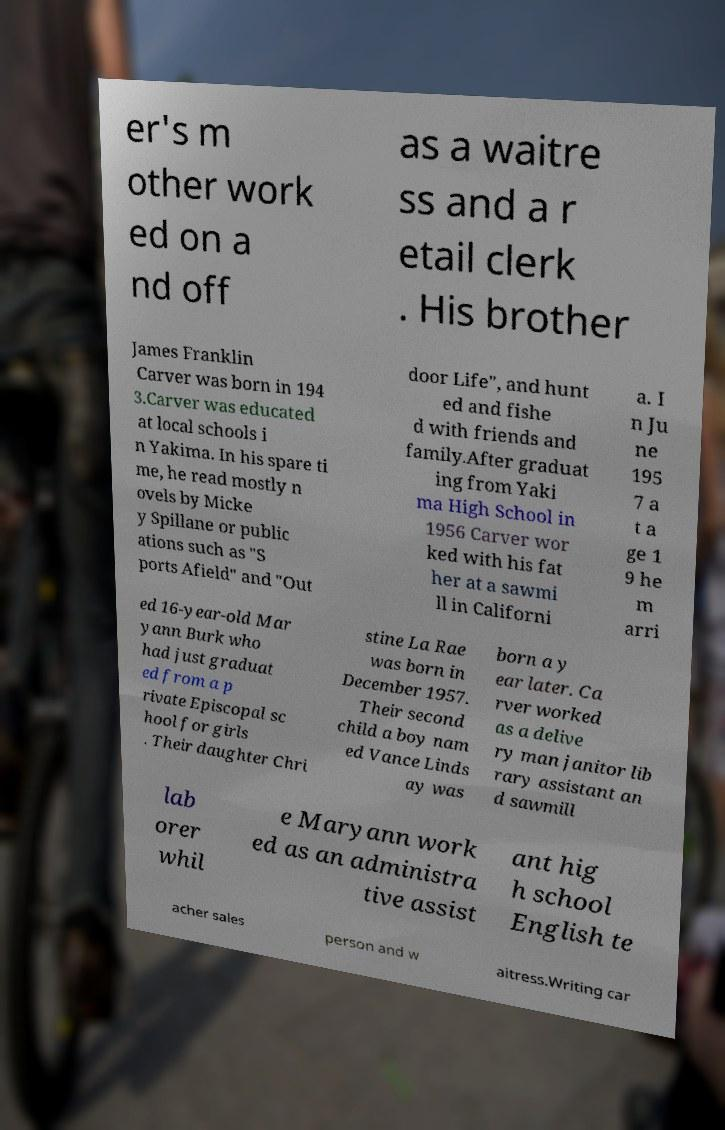Could you extract and type out the text from this image? er's m other work ed on a nd off as a waitre ss and a r etail clerk . His brother James Franklin Carver was born in 194 3.Carver was educated at local schools i n Yakima. In his spare ti me, he read mostly n ovels by Micke y Spillane or public ations such as "S ports Afield" and "Out door Life", and hunt ed and fishe d with friends and family.After graduat ing from Yaki ma High School in 1956 Carver wor ked with his fat her at a sawmi ll in Californi a. I n Ju ne 195 7 a t a ge 1 9 he m arri ed 16-year-old Mar yann Burk who had just graduat ed from a p rivate Episcopal sc hool for girls . Their daughter Chri stine La Rae was born in December 1957. Their second child a boy nam ed Vance Linds ay was born a y ear later. Ca rver worked as a delive ry man janitor lib rary assistant an d sawmill lab orer whil e Maryann work ed as an administra tive assist ant hig h school English te acher sales person and w aitress.Writing car 